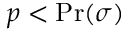Convert formula to latex. <formula><loc_0><loc_0><loc_500><loc_500>p < \Pr ( \sigma )</formula> 